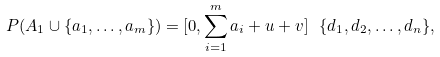<formula> <loc_0><loc_0><loc_500><loc_500>P ( A _ { 1 } \cup \{ a _ { 1 } , \dots , a _ { m } \} ) = [ 0 , \sum _ { i = 1 } ^ { m } a _ { i } + u + v ] \ \{ d _ { 1 } , d _ { 2 } , \dots , d _ { n } \} ,</formula> 